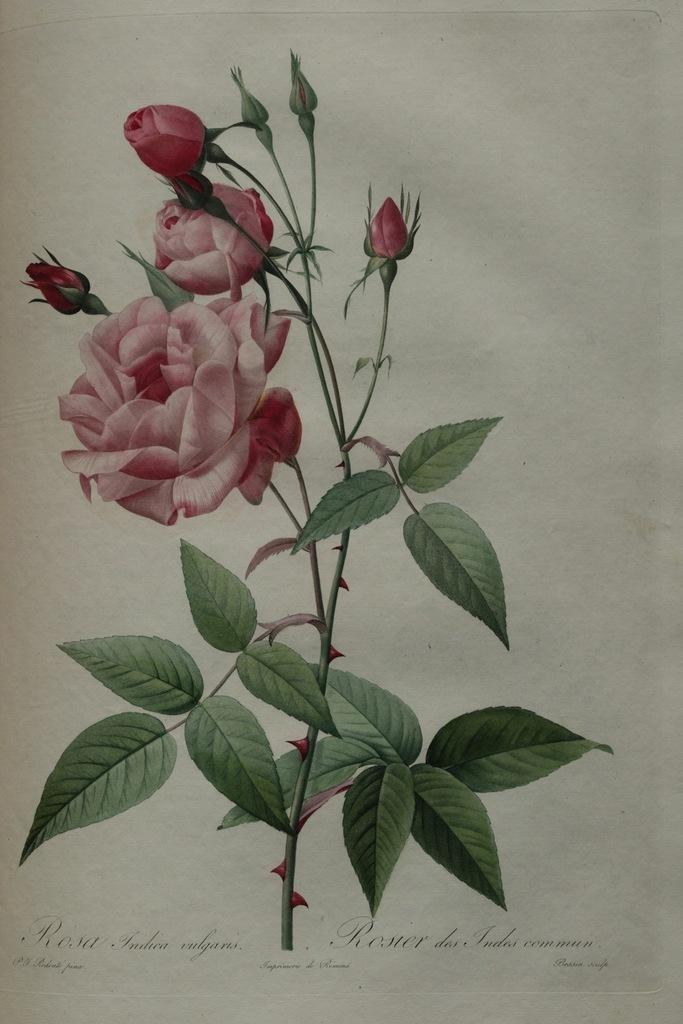What is depicted in the image? There is a painting of a rose flower plant in the image. What additional information is provided below the painting? There is text below the painting. Can you tell me how many monkeys are climbing on the rose flower plant in the image? There are no monkeys present in the image; it features a painting of a rose flower plant with text below it. 